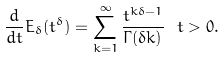<formula> <loc_0><loc_0><loc_500><loc_500>\frac { d } { d t } E _ { \delta } ( t ^ { \delta } ) = \sum _ { k = 1 } ^ { \infty } \frac { t ^ { k \delta - 1 } } { \Gamma ( \delta k ) } \ t > 0 .</formula> 